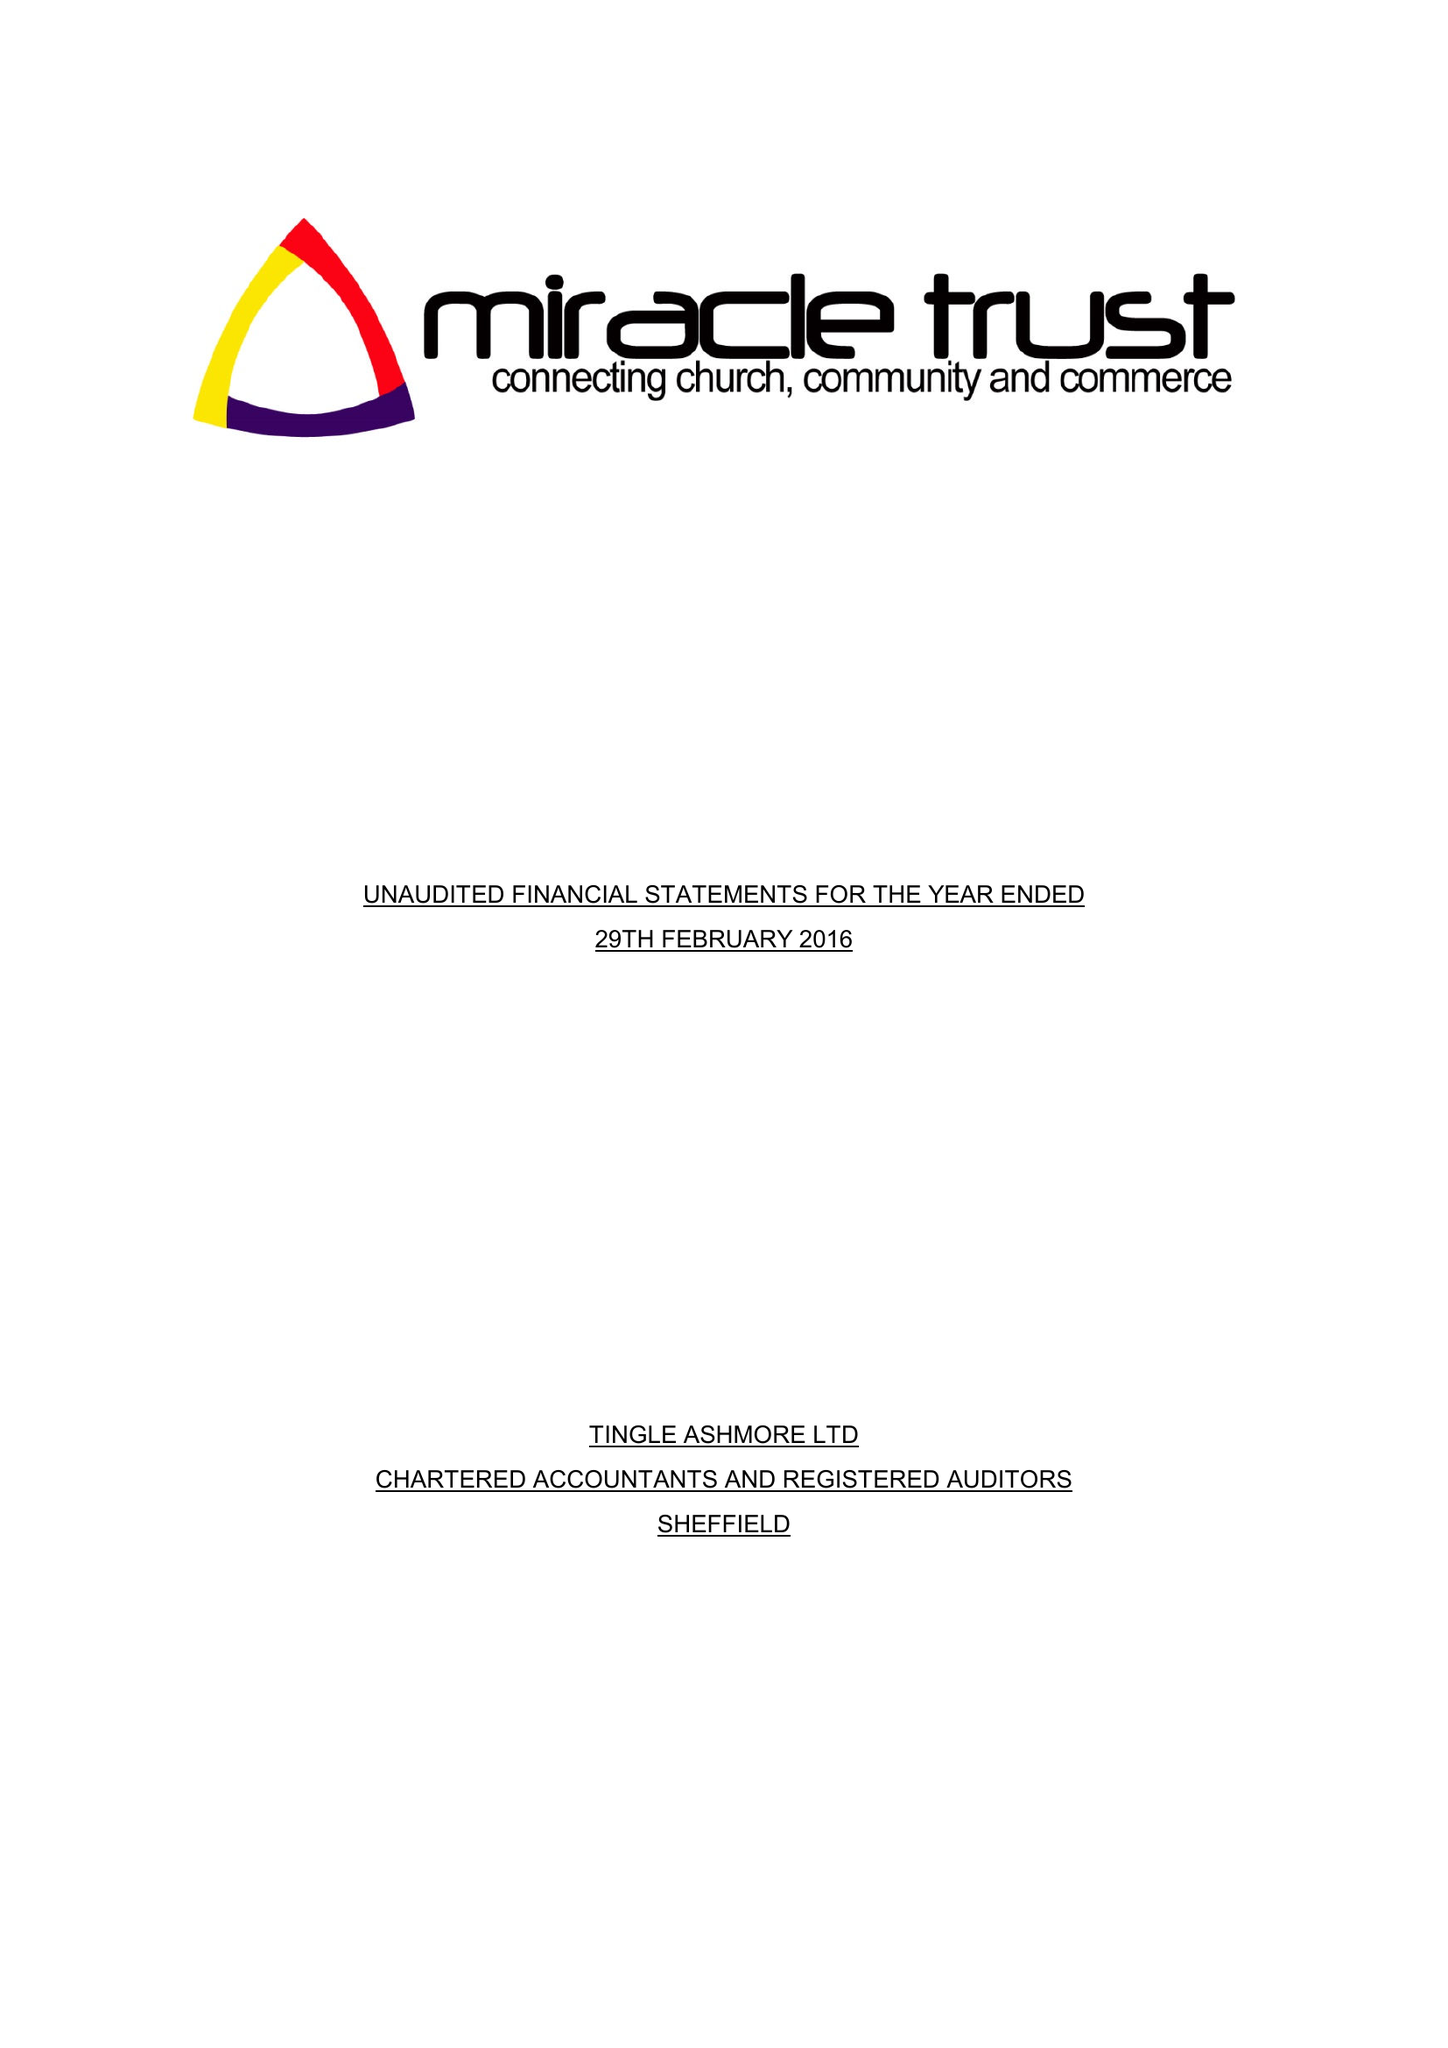What is the value for the income_annually_in_british_pounds?
Answer the question using a single word or phrase. 78262.00 